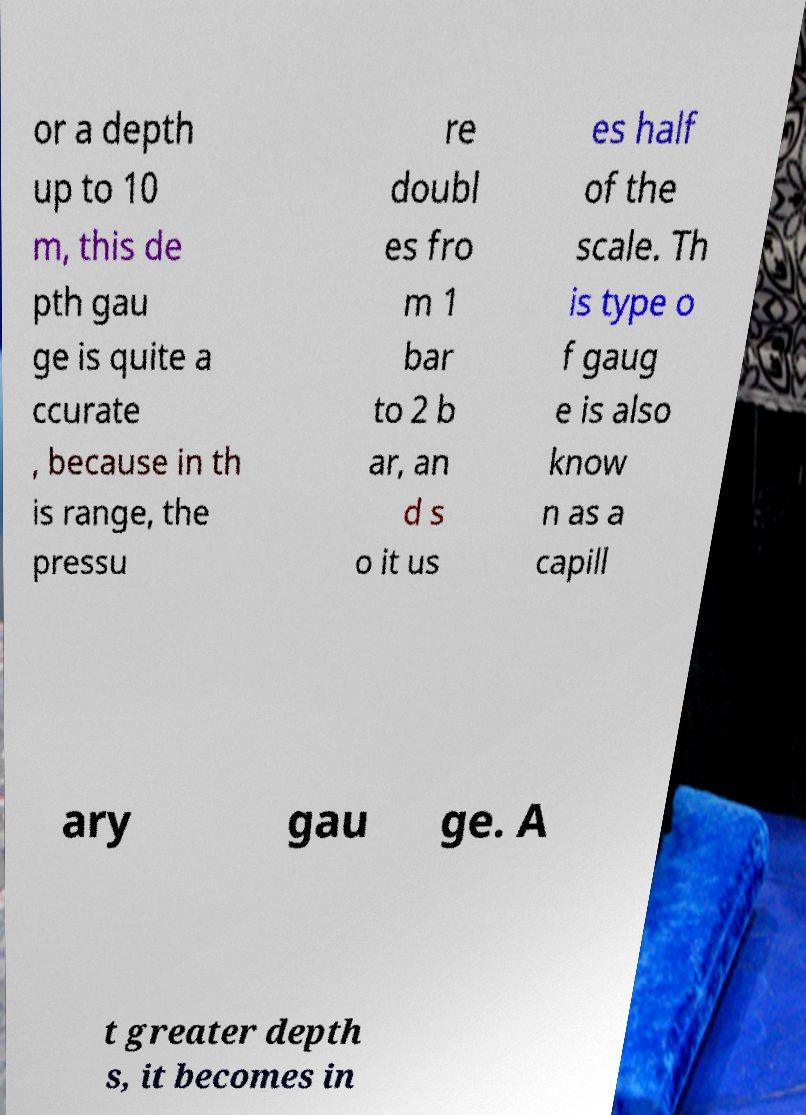What messages or text are displayed in this image? I need them in a readable, typed format. or a depth up to 10 m, this de pth gau ge is quite a ccurate , because in th is range, the pressu re doubl es fro m 1 bar to 2 b ar, an d s o it us es half of the scale. Th is type o f gaug e is also know n as a capill ary gau ge. A t greater depth s, it becomes in 